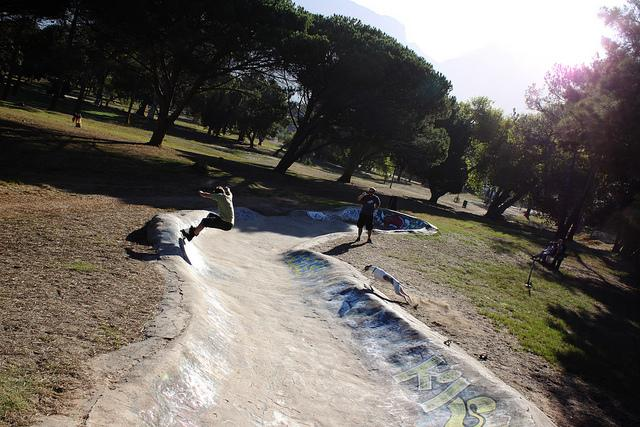Which person could be attacked by the dog first?

Choices:
A) black shirt
B) green shirt
C) red shirt
D) white shirt green shirt 